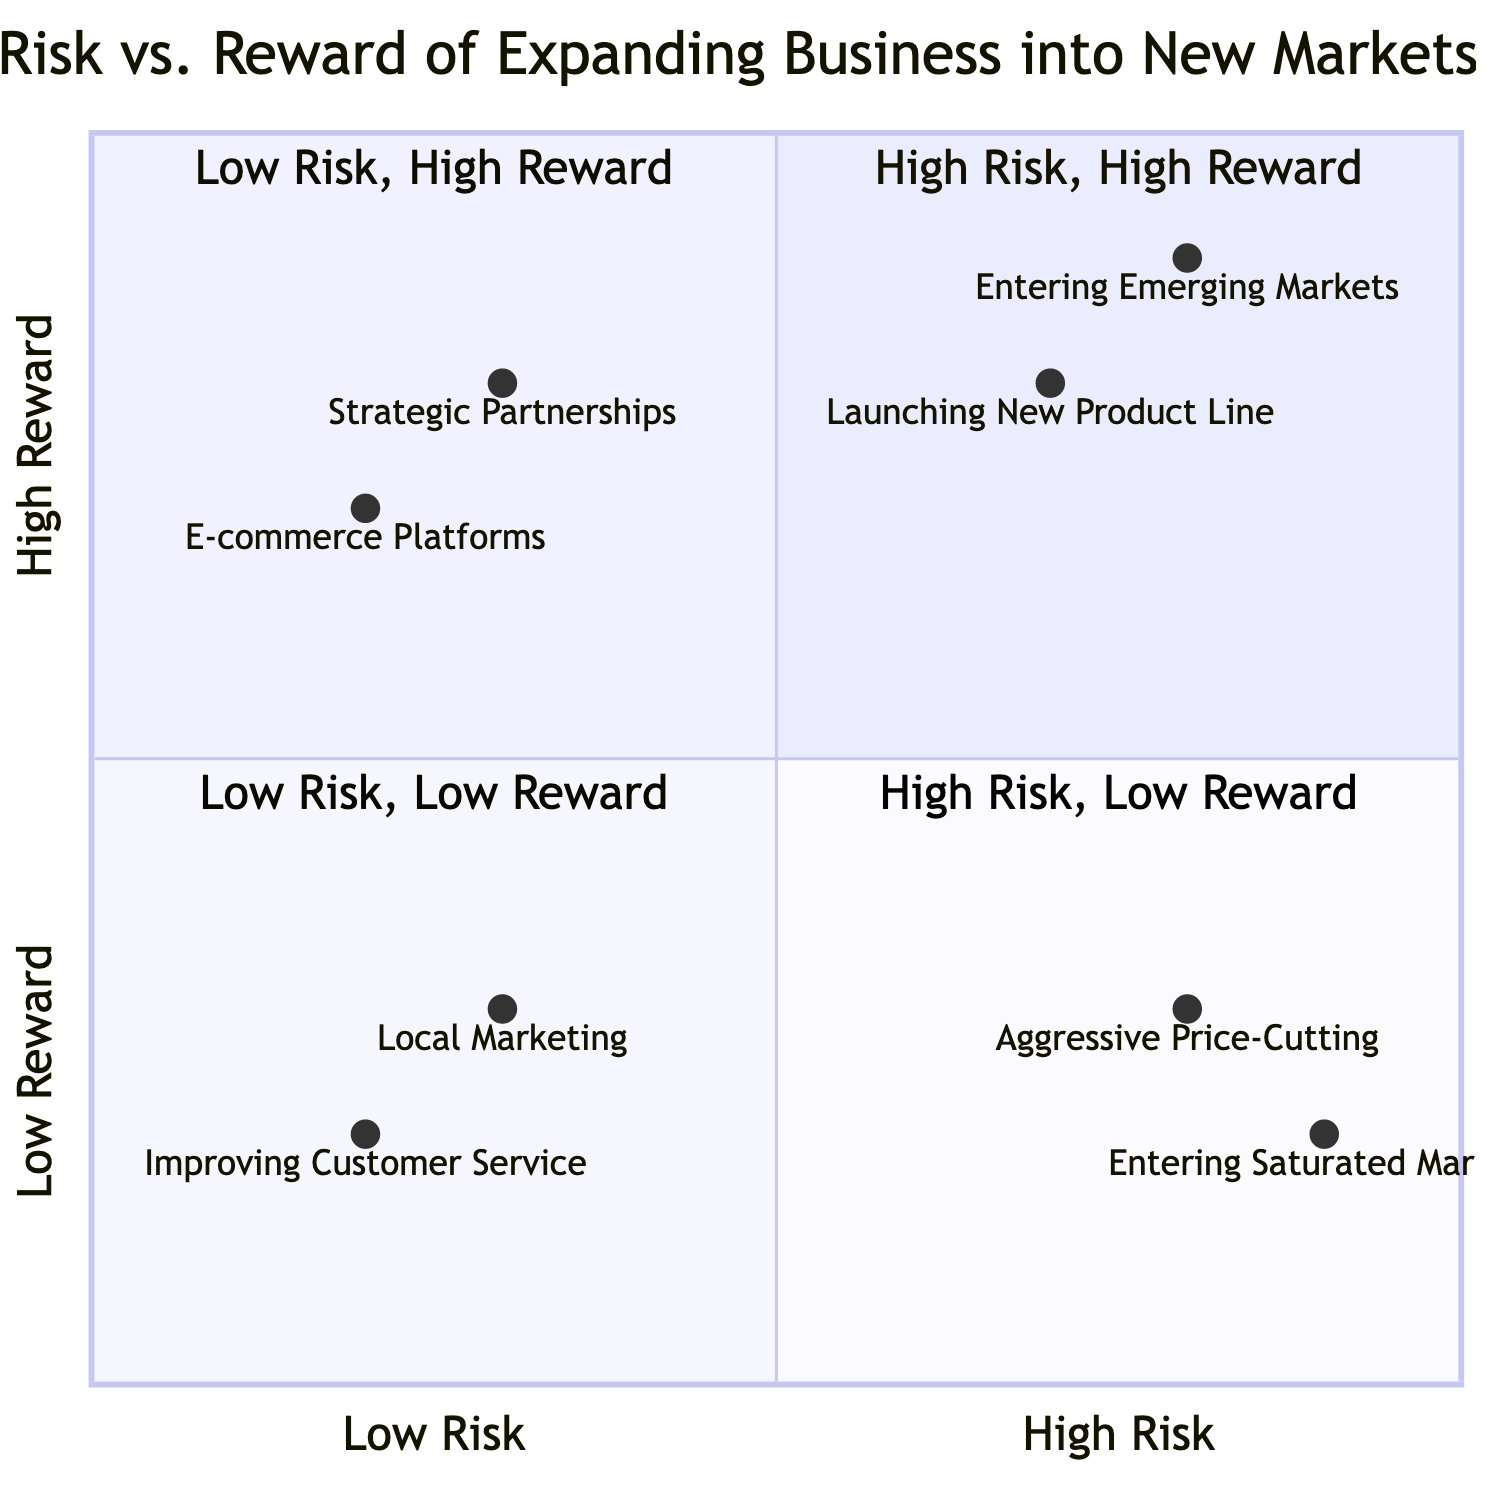What are the two entries in the High Risk, High Reward quadrant? The High Risk, High Reward quadrant lists "Entering Emerging Markets" and "Launching a New Product Line". This can be verified by locating this quadrant and reading the titles of the entries there.
Answer: Entering Emerging Markets, Launching a New Product Line How many entries are in the Low Risk, Low Reward quadrant? The Low Risk, Low Reward quadrant contains two entries: "Increasing Local Marketing Efforts" and "Improving Customer Service". Counting these entries gives a total of two.
Answer: 2 Which entry has the lowest reward? In the quadrant chart, "Improving Customer Service" appears in the Low Risk, Low Reward quadrant, and it has the lowest reward value. By analyzing the y-axis values, we find that its reward rating is the lowest at 0.2.
Answer: Improving Customer Service What is the risk level of "Leveraging E-commerce Platforms"? "Leveraging E-commerce Platforms" is located in the Low Risk, High Reward quadrant. It has a risk rating of 0.2, indicating a low risk. This can be confirmed by verifying its position on the x-axis of the chart.
Answer: Low Risk Which strategy falls under both High Risk and Low Reward? The "Entering Saturated Markets" strategy is in the High Risk, Low Reward quadrant, with the highest x-axis (risk) value of 0.9 and the lowest y-axis (reward) value of 0.2. Thus, it falls under both categories.
Answer: Entering Saturated Markets Which quadrant contains the most favorable risk-to-reward ratio? The Low Risk, High Reward quadrant contains "Strategic Partnerships" and "Leveraging E-commerce Platforms", indicating a more favorable risk-to-reward ratio compared to the others. This is determined by assessing the risk as low and rewards as high.
Answer: Low Risk, High Reward Which entry offers the highest reward with minimal risk? "Strategic Partnerships" is the entry with the highest reward at 0.8 while retaining low risk at 0.3. This is determined by examining both its x and y values in the respective quadrant.
Answer: Strategic Partnerships How many strategies listed are classified as High Risk? There are four strategies classified as High Risk, which include "Entering Emerging Markets," "Launching a New Product Line," "Aggressive Price-Cutting Strategy," and "Entering Saturated Markets." Counting these entries reveals the total.
Answer: 4 What does the Low Risk, High Reward quadrant suggest about possible business strategies? This quadrant implies that forming strategic partnerships and leveraging e-commerce platforms can expand business opportunities with minimal risk, encouraging such investments for better growth potential. It supports safe expansion strategies with high potential returns.
Answer: Forming Strategic Partnerships, Leveraging E-commerce Platforms 